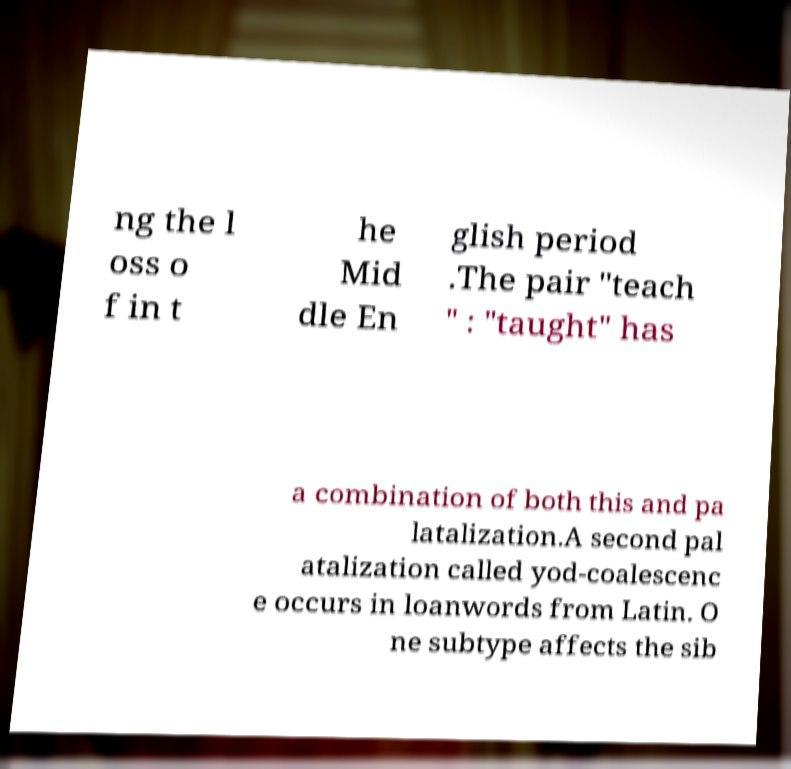Can you accurately transcribe the text from the provided image for me? ng the l oss o f in t he Mid dle En glish period .The pair "teach " : "taught" has a combination of both this and pa latalization.A second pal atalization called yod-coalescenc e occurs in loanwords from Latin. O ne subtype affects the sib 